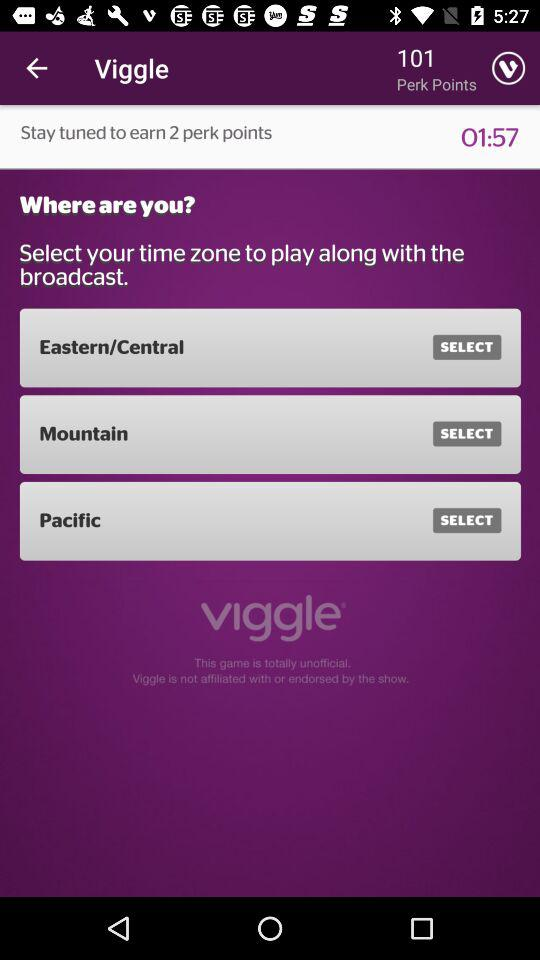How many perk points in total are there? There are 101 perk points in total. 